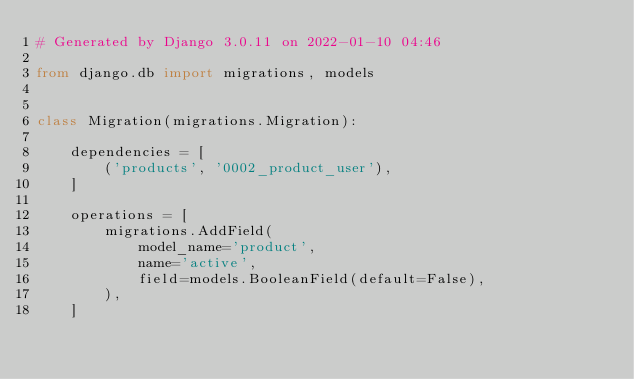Convert code to text. <code><loc_0><loc_0><loc_500><loc_500><_Python_># Generated by Django 3.0.11 on 2022-01-10 04:46

from django.db import migrations, models


class Migration(migrations.Migration):

    dependencies = [
        ('products', '0002_product_user'),
    ]

    operations = [
        migrations.AddField(
            model_name='product',
            name='active',
            field=models.BooleanField(default=False),
        ),
    ]
</code> 